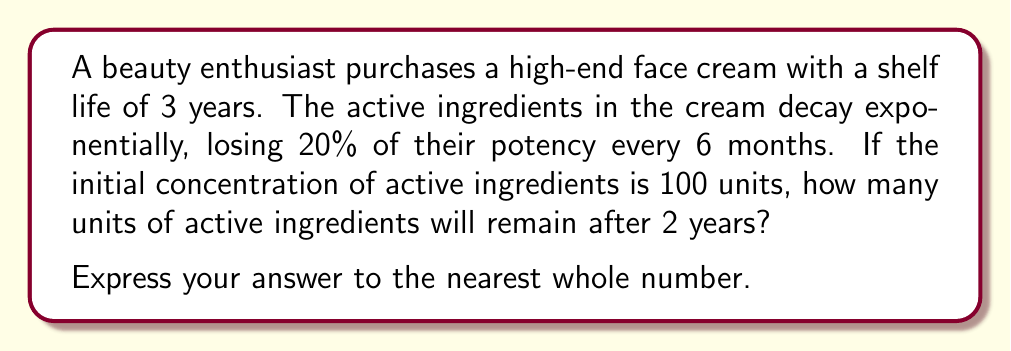Can you solve this math problem? Let's approach this step-by-step:

1) First, we need to identify the key components of the exponential decay formula:
   $A = A_0 \cdot (1-r)^t$
   Where:
   $A$ = Final amount
   $A_0$ = Initial amount (100 units)
   $r$ = Decay rate per period (20% or 0.20)
   $t$ = Number of periods

2) We know that 20% decay occurs every 6 months. In 2 years, there are 4 six-month periods.
   So, $t = 4$

3) Now, let's plug these values into our formula:
   $A = 100 \cdot (1-0.20)^4$

4) Simplify inside the parentheses:
   $A = 100 \cdot (0.80)^4$

5) Calculate the exponent:
   $A = 100 \cdot 0.4096$

6) Multiply:
   $A = 40.96$

7) Rounding to the nearest whole number:
   $A \approx 41$

Therefore, after 2 years, approximately 41 units of active ingredients will remain.
Answer: 41 units 